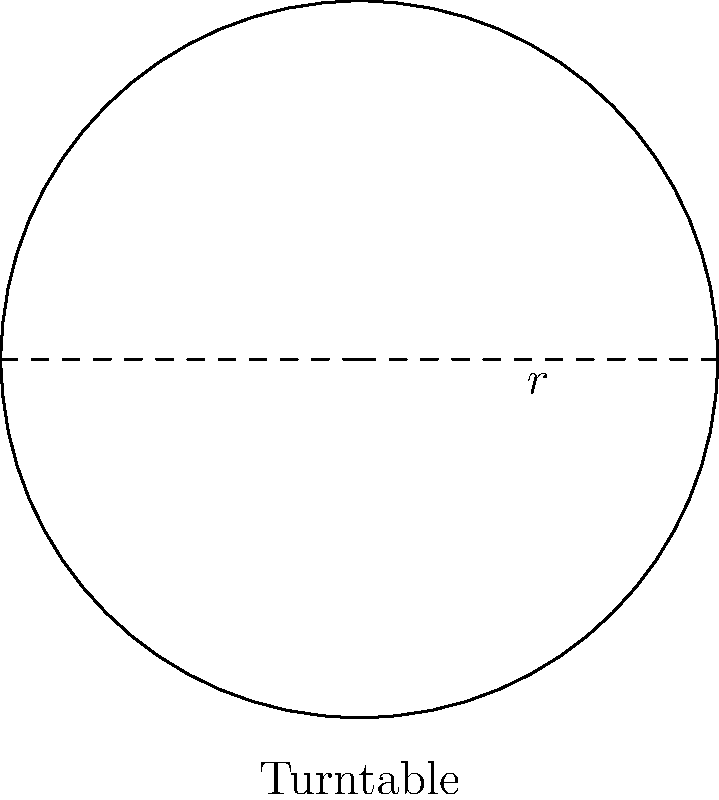A historical locomotive maintenance facility plans to install a circular turntable for efficiently rotating engines. If the radius of the turntable is 15 meters, what is the total area of land required for the turntable installation, rounded to the nearest square meter? To find the area of land required for the circular turntable, we need to calculate the area of a circle. Let's approach this step-by-step:

1) The formula for the area of a circle is:
   $$A = \pi r^2$$
   Where $A$ is the area and $r$ is the radius.

2) We are given that the radius is 15 meters.

3) Let's substitute this into our formula:
   $$A = \pi (15)^2$$

4) Simplify the exponent:
   $$A = \pi (225)$$

5) Now, let's use 3.14159 as an approximation for $\pi$:
   $$A = 3.14159 \times 225$$

6) Calculate:
   $$A = 706.85775\text{ m}^2$$

7) Rounding to the nearest square meter:
   $$A \approx 707\text{ m}^2$$

Therefore, the total area of land required for the turntable installation is approximately 707 square meters.
Answer: 707 m² 